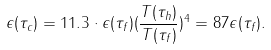Convert formula to latex. <formula><loc_0><loc_0><loc_500><loc_500>\epsilon ( \tau _ { c } ) = 1 1 . 3 \cdot \epsilon ( \tau _ { f } ) ( \frac { T ( \tau _ { h } ) } { T ( \tau _ { f } ) } ) ^ { 4 } = 8 7 \epsilon ( \tau _ { f } ) .</formula> 